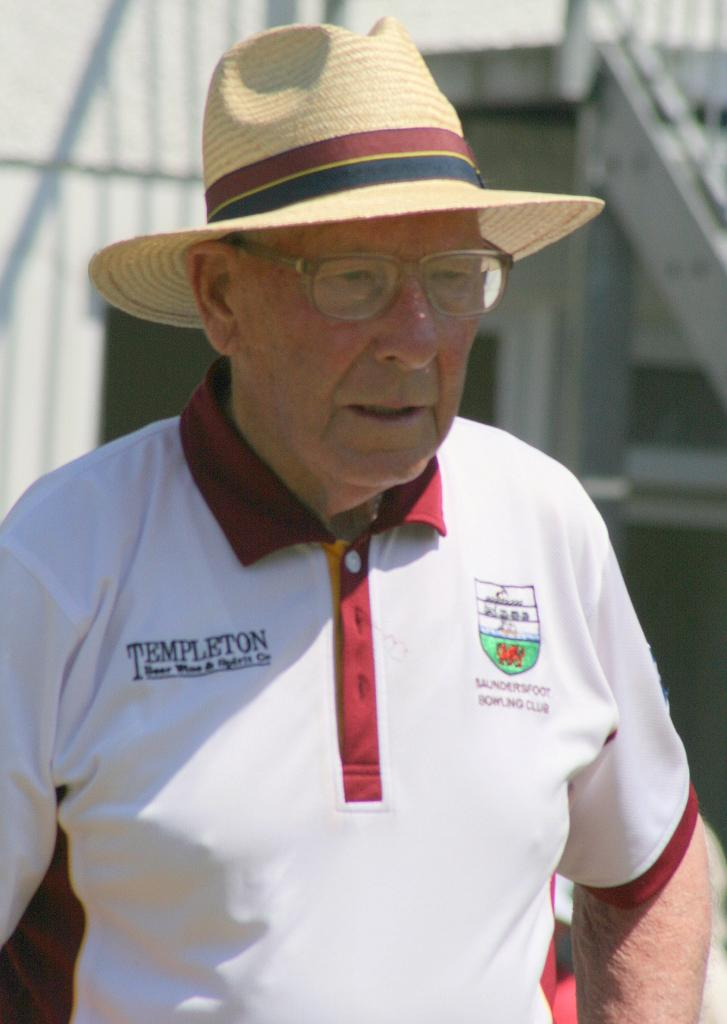<image>
Present a compact description of the photo's key features. An older man wearing a sunhat, glasses, and a white polo shirt that says Templeton. 